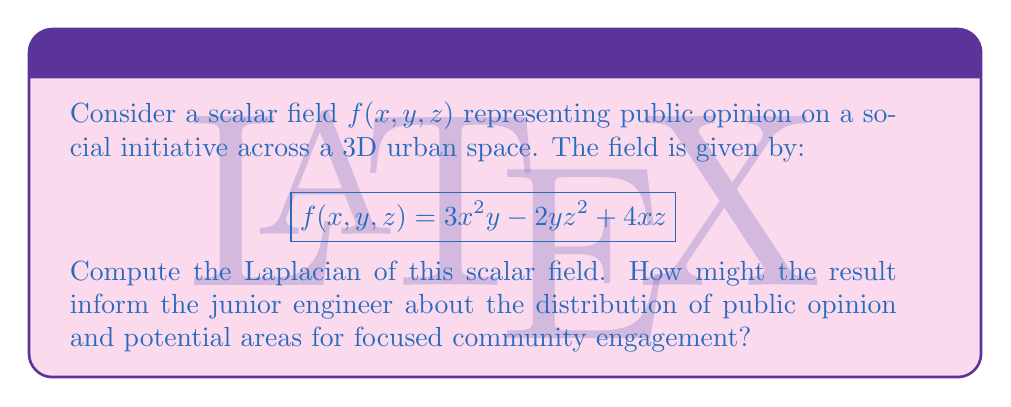Can you solve this math problem? To solve this problem, we'll follow these steps:

1) Recall that the Laplacian of a scalar field $f(x,y,z)$ in 3D Cartesian coordinates is given by:

   $$\nabla^2f = \frac{\partial^2f}{\partial x^2} + \frac{\partial^2f}{\partial y^2} + \frac{\partial^2f}{\partial z^2}$$

2) Let's compute each second partial derivative:

   a) $\frac{\partial f}{\partial x} = 6xy + 4z$
      $\frac{\partial^2f}{\partial x^2} = 6y$

   b) $\frac{\partial f}{\partial y} = 3x^2 - 2z^2$
      $\frac{\partial^2f}{\partial y^2} = 0$

   c) $\frac{\partial f}{\partial z} = -4yz + 4x$
      $\frac{\partial^2f}{\partial z^2} = -4y$

3) Now, we sum these second partial derivatives:

   $$\nabla^2f = 6y + 0 + (-4y) = 2y$$

The Laplacian represents the divergence of the gradient of the scalar field. In this context, it indicates how public opinion varies across the urban space. 

The result $2y$ suggests that:
- The rate of change of public opinion is constant along the y-axis.
- There's no dependence on x or z, indicating uniform opinion distribution in those directions.
- Positive y values show increasing support, while negative y values show decreasing support.

This information can guide the junior engineer to:
1. Focus community engagement efforts along the y-axis.
2. Investigate what factors along the y-axis might be influencing public opinion.
3. Develop targeted strategies for areas with positive and negative y values.
Answer: The Laplacian of the scalar field is $\nabla^2f = 2y$. 